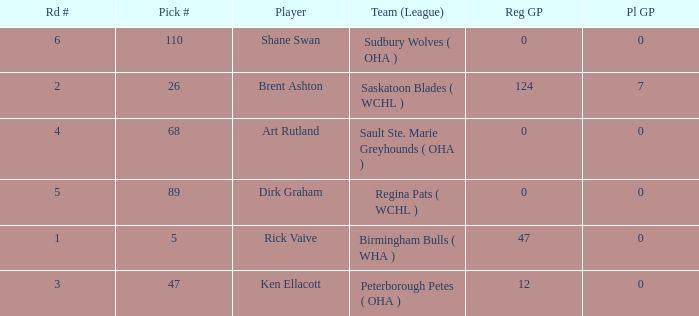How many reg GP for rick vaive in round 1? None. 